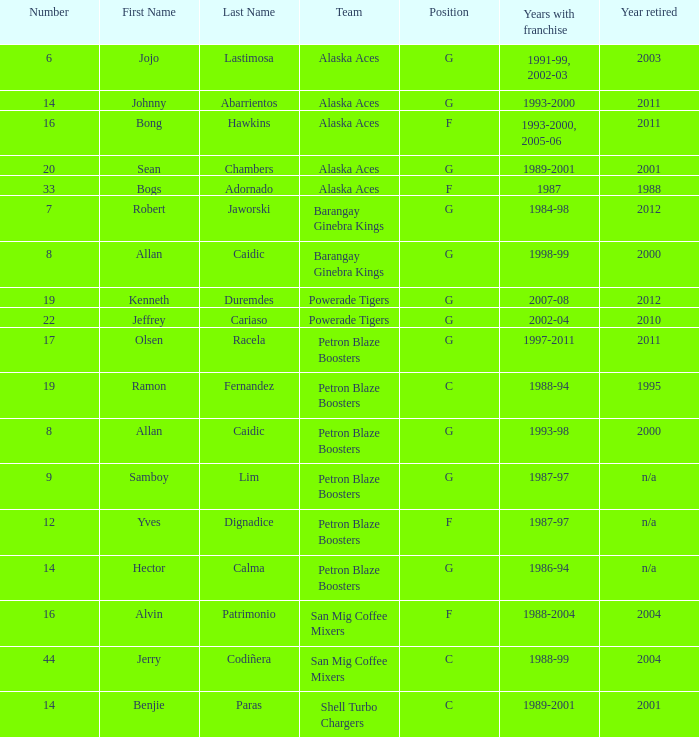Who was the player in Position G on the Petron Blaze Boosters and retired in 2000? Allan Caidic Category:Articles with hCards. 